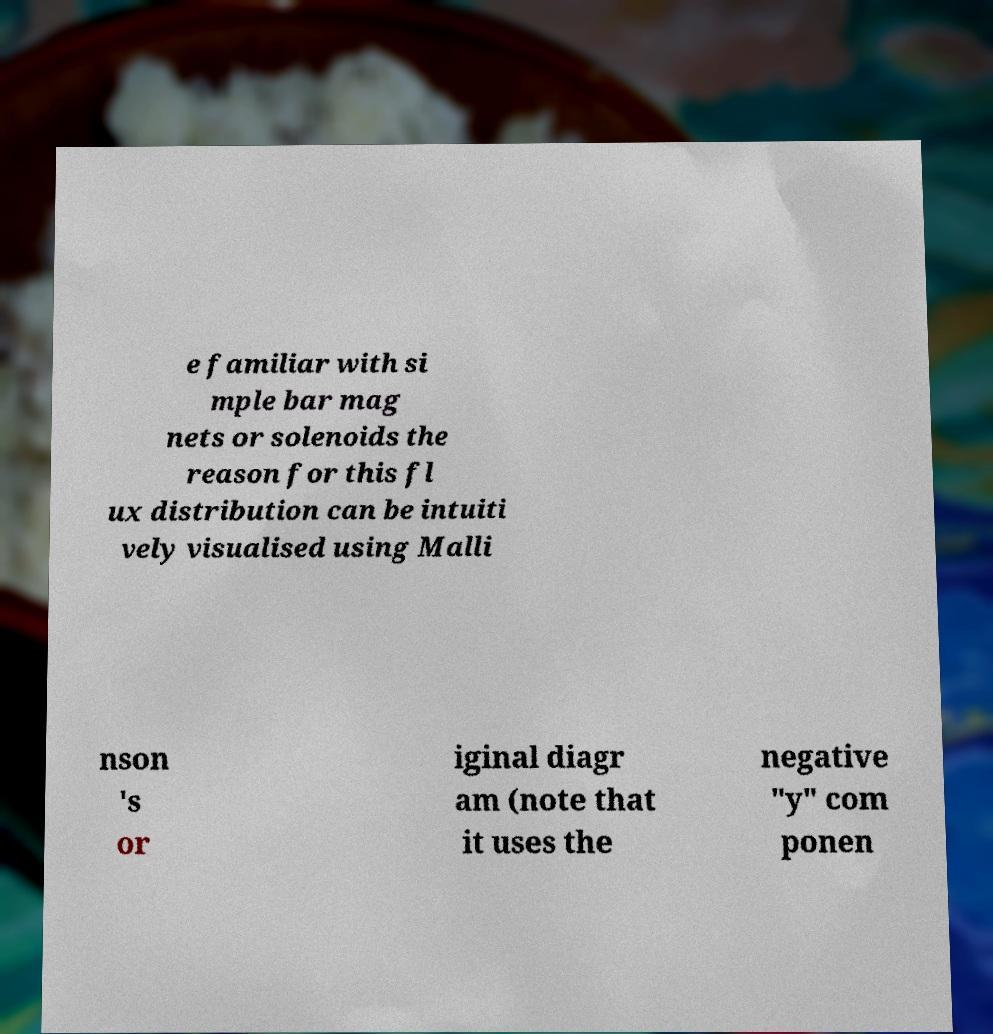Can you read and provide the text displayed in the image?This photo seems to have some interesting text. Can you extract and type it out for me? e familiar with si mple bar mag nets or solenoids the reason for this fl ux distribution can be intuiti vely visualised using Malli nson 's or iginal diagr am (note that it uses the negative "y" com ponen 